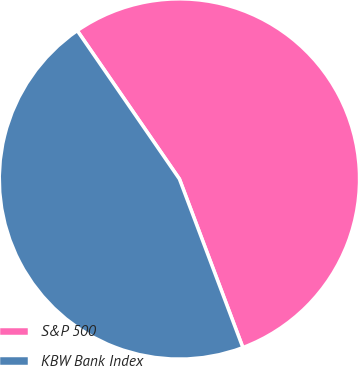Convert chart to OTSL. <chart><loc_0><loc_0><loc_500><loc_500><pie_chart><fcel>S&P 500<fcel>KBW Bank Index<nl><fcel>53.87%<fcel>46.13%<nl></chart> 